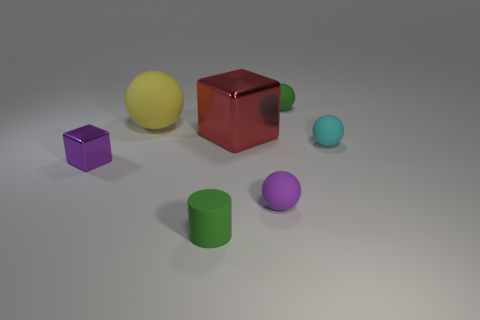Subtract all brown balls. Subtract all green cylinders. How many balls are left? 4 Add 2 small green cylinders. How many objects exist? 9 Subtract all spheres. How many objects are left? 3 Subtract 1 purple cubes. How many objects are left? 6 Subtract all purple spheres. Subtract all tiny purple metal cubes. How many objects are left? 5 Add 5 green objects. How many green objects are left? 7 Add 3 small green matte objects. How many small green matte objects exist? 5 